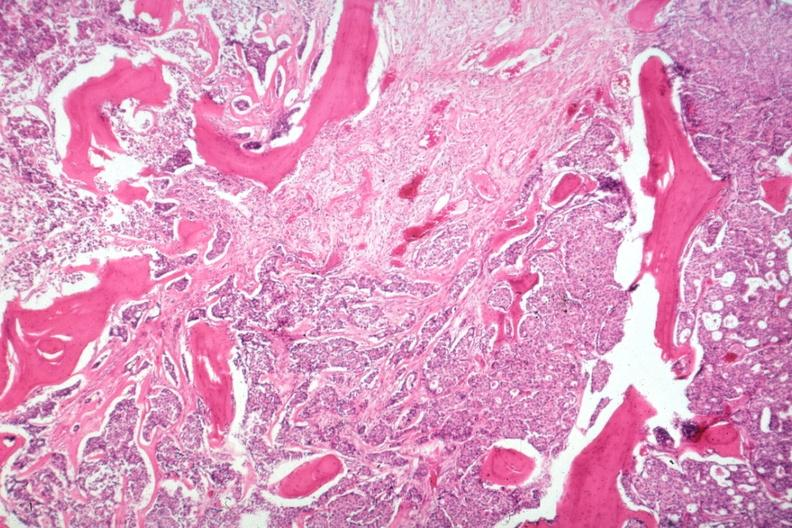what is gross of tumor?
Answer the question using a single word or phrase. Islands 